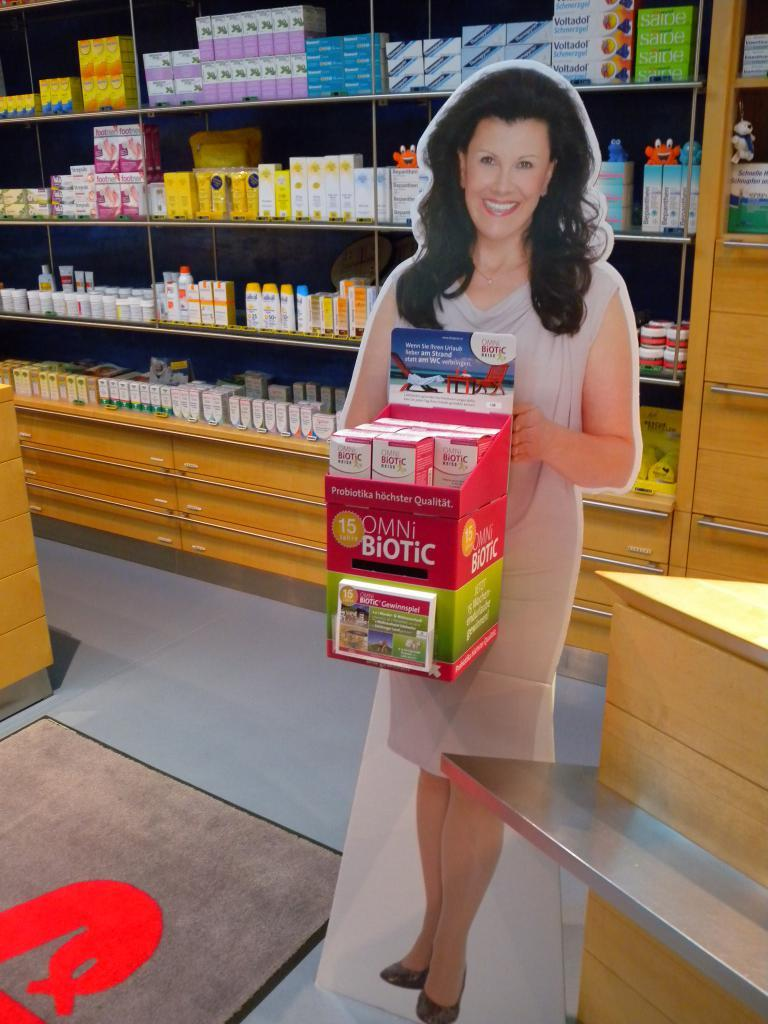<image>
Relay a brief, clear account of the picture shown. A cutout picture stand of a woman holding a box of biotic products in a store. 